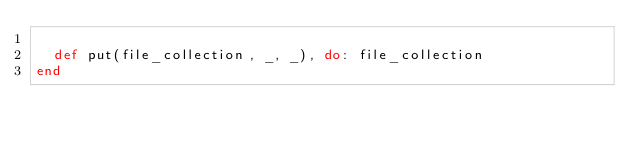<code> <loc_0><loc_0><loc_500><loc_500><_Elixir_>
  def put(file_collection, _, _), do: file_collection
end
</code> 